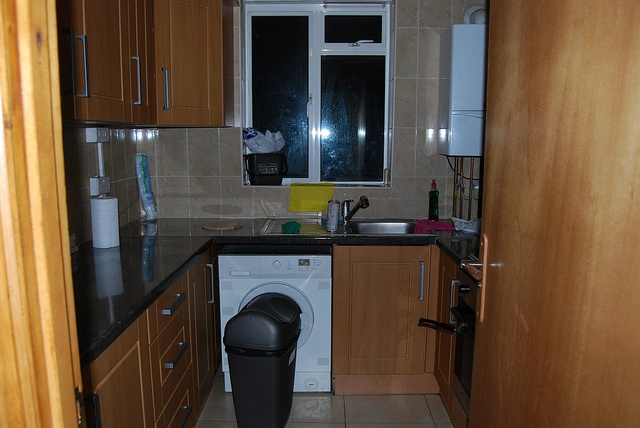Describe the objects in this image and their specific colors. I can see sink in tan, gray, black, and darkgray tones and bottle in tan, black, maroon, gray, and blue tones in this image. 